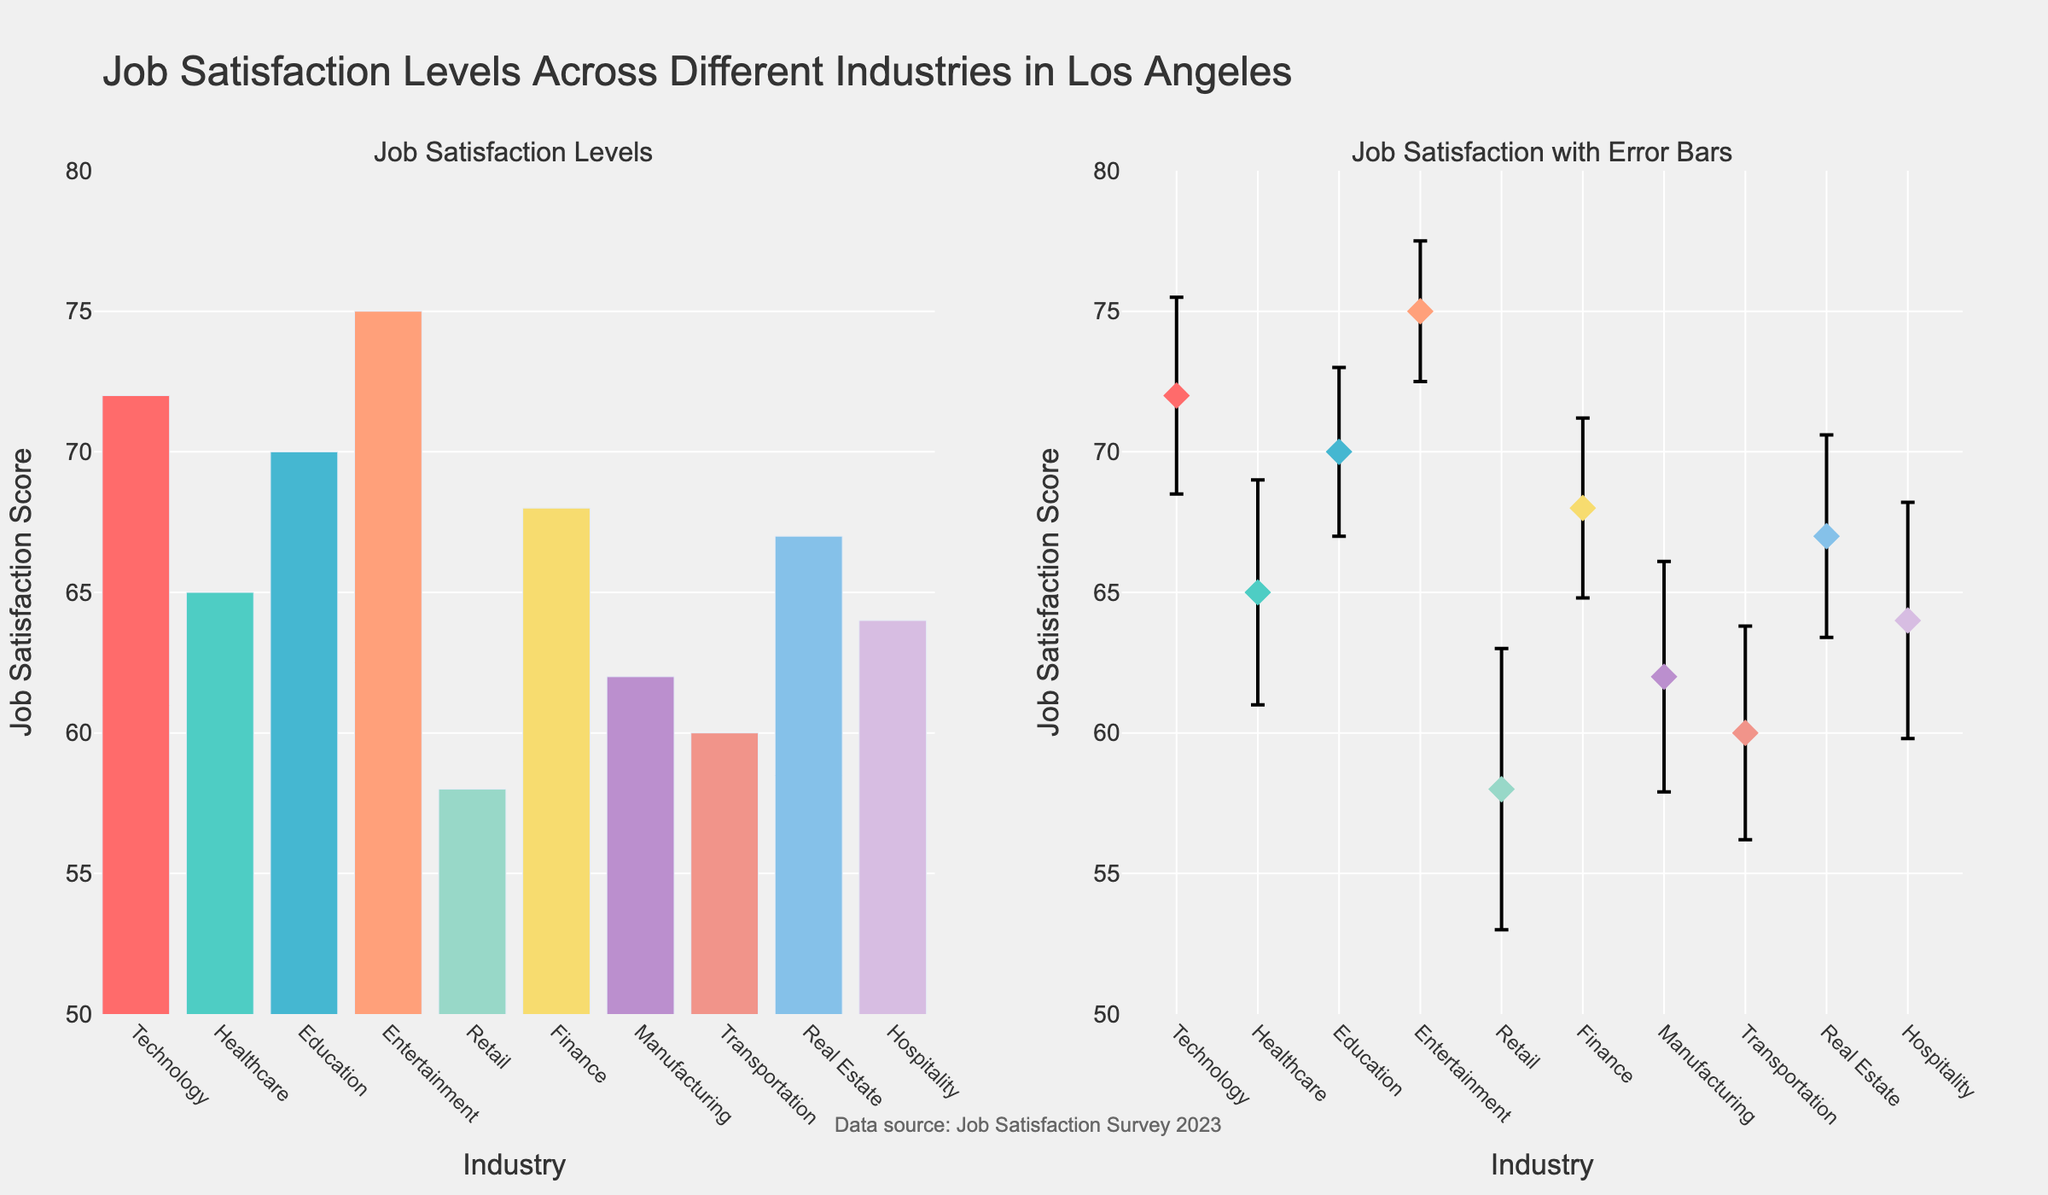Which industry has the highest mean job satisfaction? The figure shows the mean job satisfaction levels for different industries. The highest bar and marker are both for the Entertainment industry.
Answer: Entertainment What is the mean job satisfaction level for the Healthcare industry? Refer to the bar and marker corresponding to the Healthcare industry. The label shows a mean job satisfaction of 65.
Answer: 65 Which industry has the largest standard error in job satisfaction? The error bars represent the standard errors of job satisfaction levels. The largest error bar is for the Retail industry.
Answer: Retail How does job satisfaction in the Finance industry compare to the Education industry? Compare the heights of the bars and markers for the Finance and Education industries. Finance has a mean job satisfaction of 68, while Education has 70.
Answer: Education has slightly higher job satisfaction What is the range of mean job satisfaction levels across all industries? Identify the highest and lowest mean job satisfaction levels. Entertainment has the highest at 75, and Retail has the lowest at 58. The range is 75 - 58.
Answer: 17 Which two industries have the closest mean job satisfaction levels? Compare the heights of all bars and markers to find the smallest difference. Finance (68) and Real Estate (67) have the closest means, differing by 1 unit.
Answer: Finance and Real Estate Can you rank the industries by mean job satisfaction from highest to lowest? List the mean job satisfaction levels in descending order.
Answer: Entertainment, Technology, Education, Finance, Real Estate, Healthcare, Hospitality, Manufacturing, Transportation, Retail What error range does the Healthcare industry cover in its job satisfaction level? Identify the mean (65) and the standard error (4) for Healthcare. The error range is 65 ± 4, which covers 61 to 69.
Answer: 61 to 69 How many industries have a mean job satisfaction above 70? Count the bars or markers with values higher than 70. Technology, Education, Entertainment are above 70.
Answer: 3 Is the mean job satisfaction of the Technology industry higher or lower than the mean of all industries combined? Calculate the overall mean by summing all means and dividing by the number of industries, then compare it to the Technology industry's mean of 72. (The overall mean is (72 + 65 + 70 + 75 + 58 + 68 + 62 + 60 + 67 + 64) / 10 = 66.1).
Answer: Higher 